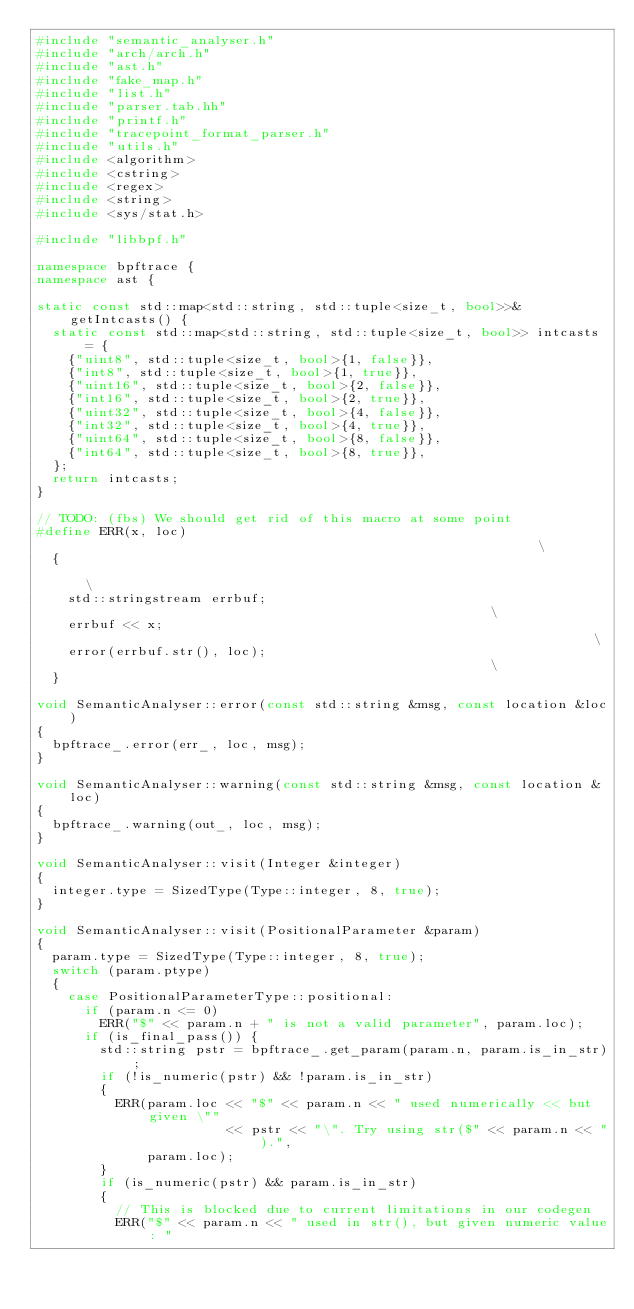Convert code to text. <code><loc_0><loc_0><loc_500><loc_500><_C++_>#include "semantic_analyser.h"
#include "arch/arch.h"
#include "ast.h"
#include "fake_map.h"
#include "list.h"
#include "parser.tab.hh"
#include "printf.h"
#include "tracepoint_format_parser.h"
#include "utils.h"
#include <algorithm>
#include <cstring>
#include <regex>
#include <string>
#include <sys/stat.h>

#include "libbpf.h"

namespace bpftrace {
namespace ast {

static const std::map<std::string, std::tuple<size_t, bool>>& getIntcasts() {
  static const std::map<std::string, std::tuple<size_t, bool>> intcasts = {
    {"uint8", std::tuple<size_t, bool>{1, false}},
    {"int8", std::tuple<size_t, bool>{1, true}},
    {"uint16", std::tuple<size_t, bool>{2, false}},
    {"int16", std::tuple<size_t, bool>{2, true}},
    {"uint32", std::tuple<size_t, bool>{4, false}},
    {"int32", std::tuple<size_t, bool>{4, true}},
    {"uint64", std::tuple<size_t, bool>{8, false}},
    {"int64", std::tuple<size_t, bool>{8, true}},
  };
  return intcasts;
}

// TODO: (fbs) We should get rid of this macro at some point
#define ERR(x, loc)                                                            \
  {                                                                            \
    std::stringstream errbuf;                                                  \
    errbuf << x;                                                               \
    error(errbuf.str(), loc);                                                  \
  }

void SemanticAnalyser::error(const std::string &msg, const location &loc)
{
  bpftrace_.error(err_, loc, msg);
}

void SemanticAnalyser::warning(const std::string &msg, const location &loc)
{
  bpftrace_.warning(out_, loc, msg);
}

void SemanticAnalyser::visit(Integer &integer)
{
  integer.type = SizedType(Type::integer, 8, true);
}

void SemanticAnalyser::visit(PositionalParameter &param)
{
  param.type = SizedType(Type::integer, 8, true);
  switch (param.ptype)
  {
    case PositionalParameterType::positional:
      if (param.n <= 0)
        ERR("$" << param.n + " is not a valid parameter", param.loc);
      if (is_final_pass()) {
        std::string pstr = bpftrace_.get_param(param.n, param.is_in_str);
        if (!is_numeric(pstr) && !param.is_in_str)
        {
          ERR(param.loc << "$" << param.n << " used numerically << but given \""
                        << pstr << "\". Try using str($" << param.n << ").",
              param.loc);
        }
        if (is_numeric(pstr) && param.is_in_str)
        {
          // This is blocked due to current limitations in our codegen
          ERR("$" << param.n << " used in str(), but given numeric value: "</code> 